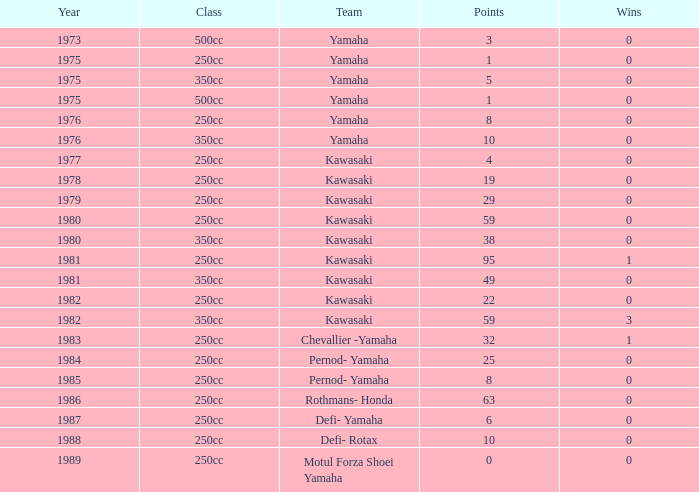What was the point tally for yamaha's 250cc class team in a year preceding 1978, when they secured more than 0 victories? 0.0. 